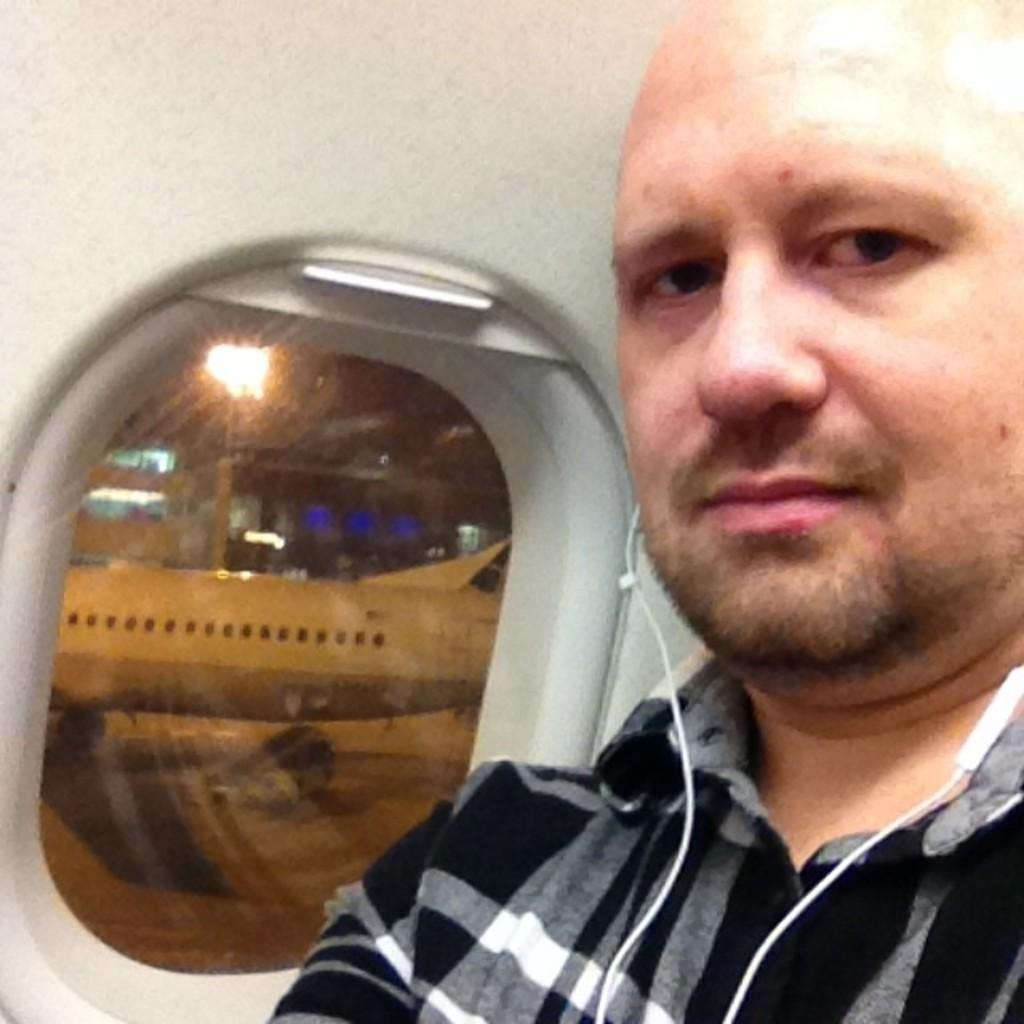What can be seen in the image? There is a person in the image. Can you describe the person's attire? The person is wearing a white and black colored dress. What is the setting of the image? The image is set inside an aeroplane, as there is a window belonging to an aeroplane. What can be seen through the window? Another aeroplane and a building are visible through the window, along with a light. What type of cat is responsible for the distribution of snacks in the image? There is no cat or distribution of snacks present in the image. 